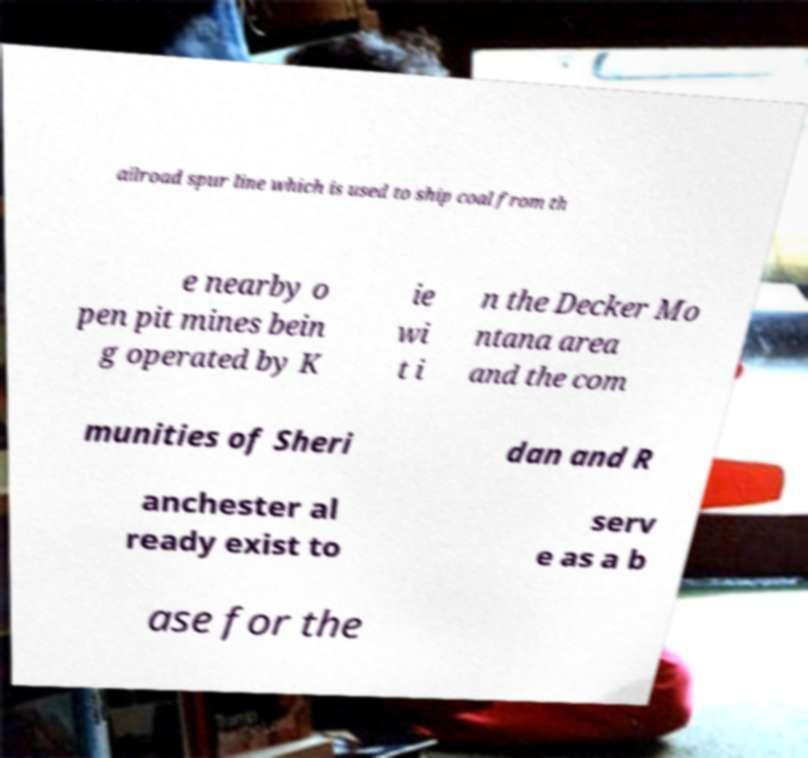Could you extract and type out the text from this image? ailroad spur line which is used to ship coal from th e nearby o pen pit mines bein g operated by K ie wi t i n the Decker Mo ntana area and the com munities of Sheri dan and R anchester al ready exist to serv e as a b ase for the 